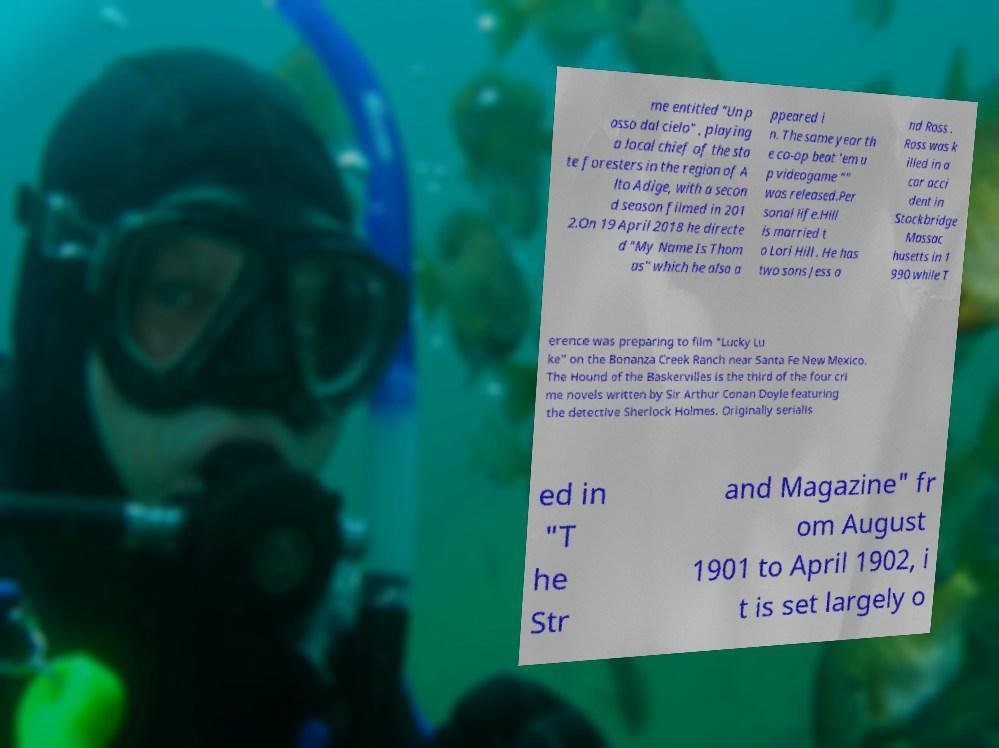Could you assist in decoding the text presented in this image and type it out clearly? me entitled "Un p asso dal cielo" , playing a local chief of the sta te foresters in the region of A lto Adige, with a secon d season filmed in 201 2.On 19 April 2018 he directe d "My Name Is Thom as" which he also a ppeared i n. The same year th e co-op beat 'em u p videogame "" was released.Per sonal life.Hill is married t o Lori Hill . He has two sons Jess a nd Ross . Ross was k illed in a car acci dent in Stockbridge Massac husetts in 1 990 while T erence was preparing to film "Lucky Lu ke" on the Bonanza Creek Ranch near Santa Fe New Mexico. The Hound of the Baskervilles is the third of the four cri me novels written by Sir Arthur Conan Doyle featuring the detective Sherlock Holmes. Originally serialis ed in "T he Str and Magazine" fr om August 1901 to April 1902, i t is set largely o 